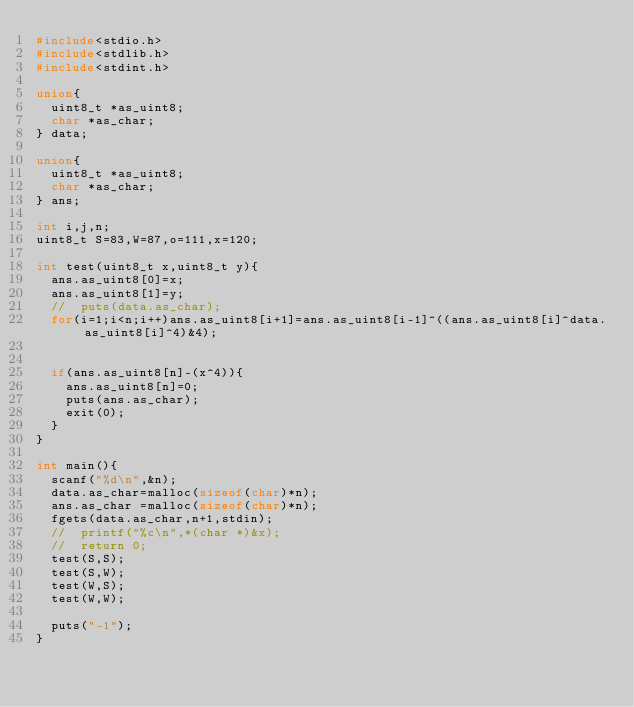Convert code to text. <code><loc_0><loc_0><loc_500><loc_500><_C_>#include<stdio.h>
#include<stdlib.h>
#include<stdint.h>

union{
  uint8_t *as_uint8;
  char *as_char;
} data;

union{
  uint8_t *as_uint8;
  char *as_char;
} ans;

int i,j,n;
uint8_t S=83,W=87,o=111,x=120;

int test(uint8_t x,uint8_t y){
  ans.as_uint8[0]=x;
  ans.as_uint8[1]=y;
  //  puts(data.as_char);
  for(i=1;i<n;i++)ans.as_uint8[i+1]=ans.as_uint8[i-1]^((ans.as_uint8[i]^data.as_uint8[i]^4)&4);


  if(ans.as_uint8[n]-(x^4)){
    ans.as_uint8[n]=0;
    puts(ans.as_char);
    exit(0);
  }
}

int main(){
  scanf("%d\n",&n);
  data.as_char=malloc(sizeof(char)*n);
  ans.as_char =malloc(sizeof(char)*n);
  fgets(data.as_char,n+1,stdin);
  //  printf("%c\n",*(char *)&x);
  //  return 0; 
  test(S,S);
  test(S,W);
  test(W,S);
  test(W,W);
  
  puts("-1");
}</code> 